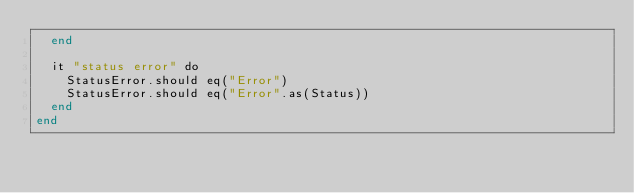Convert code to text. <code><loc_0><loc_0><loc_500><loc_500><_Crystal_>  end

  it "status error" do
    StatusError.should eq("Error")
    StatusError.should eq("Error".as(Status))
  end
end
</code> 